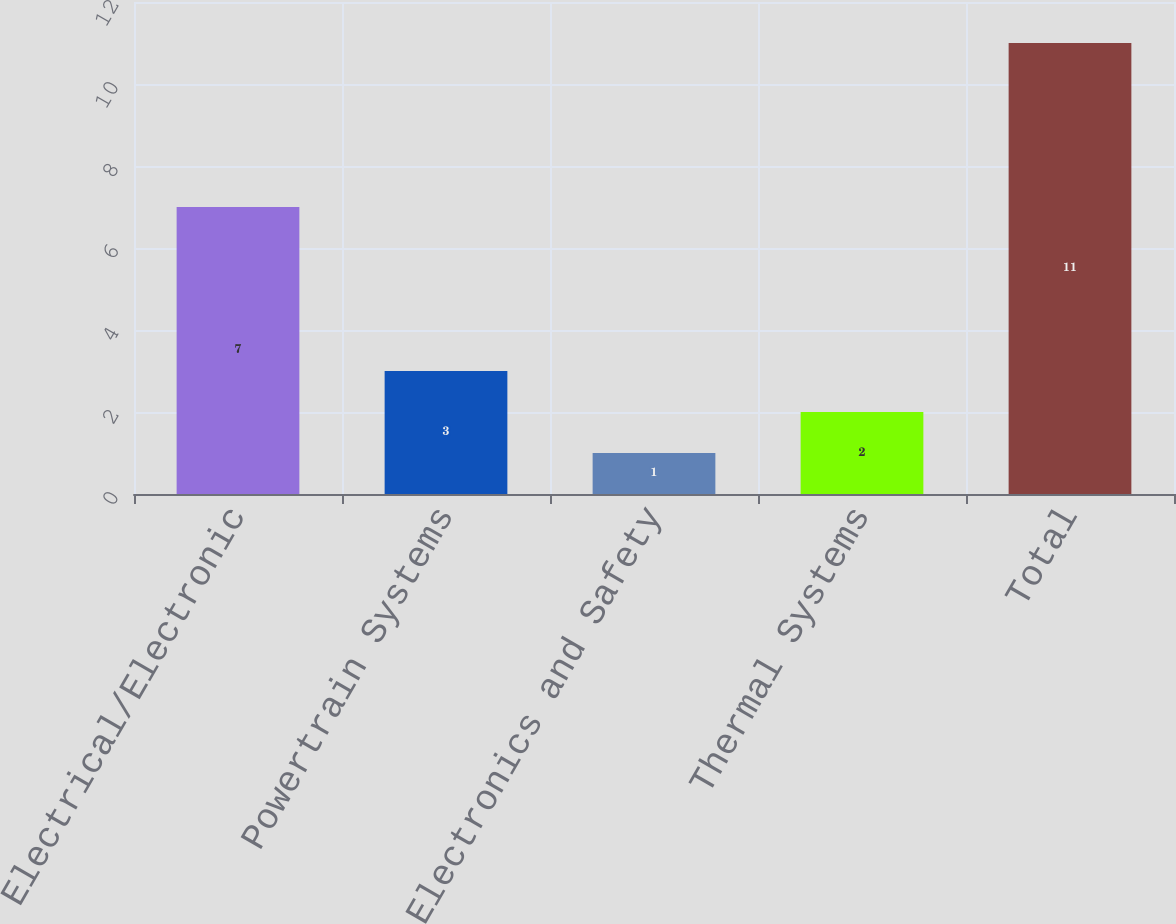Convert chart to OTSL. <chart><loc_0><loc_0><loc_500><loc_500><bar_chart><fcel>Electrical/Electronic<fcel>Powertrain Systems<fcel>Electronics and Safety<fcel>Thermal Systems<fcel>Total<nl><fcel>7<fcel>3<fcel>1<fcel>2<fcel>11<nl></chart> 